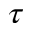<formula> <loc_0><loc_0><loc_500><loc_500>\tau</formula> 